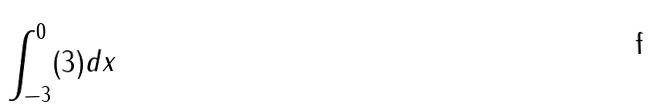<formula> <loc_0><loc_0><loc_500><loc_500>\int _ { - 3 } ^ { 0 } ( 3 ) d x</formula> 